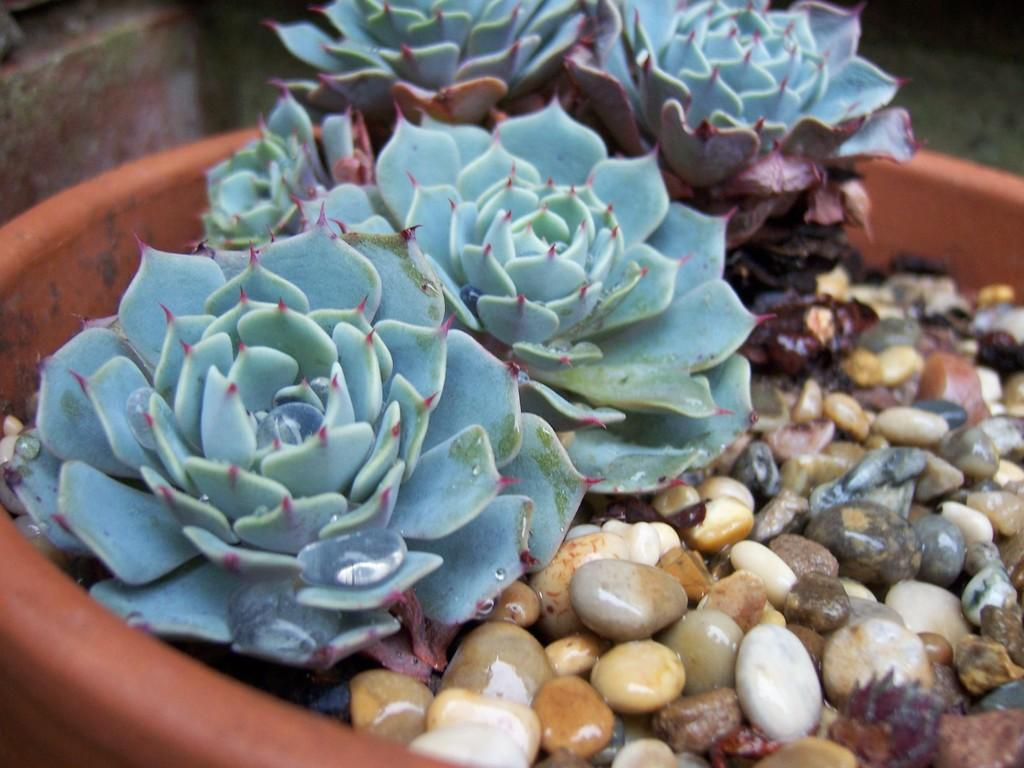What type of plants are in the image? There are plants with flower-like leaves in the image. Can you describe the arrangement of the plants? The plants are in a flower pot on the right side of the image. What else can be found in the flower pot? There are stones in the flower pot on the right side of the image. What is the creator's opinion about the plants in the image? There is no information about a creator or their opinion in the image. 